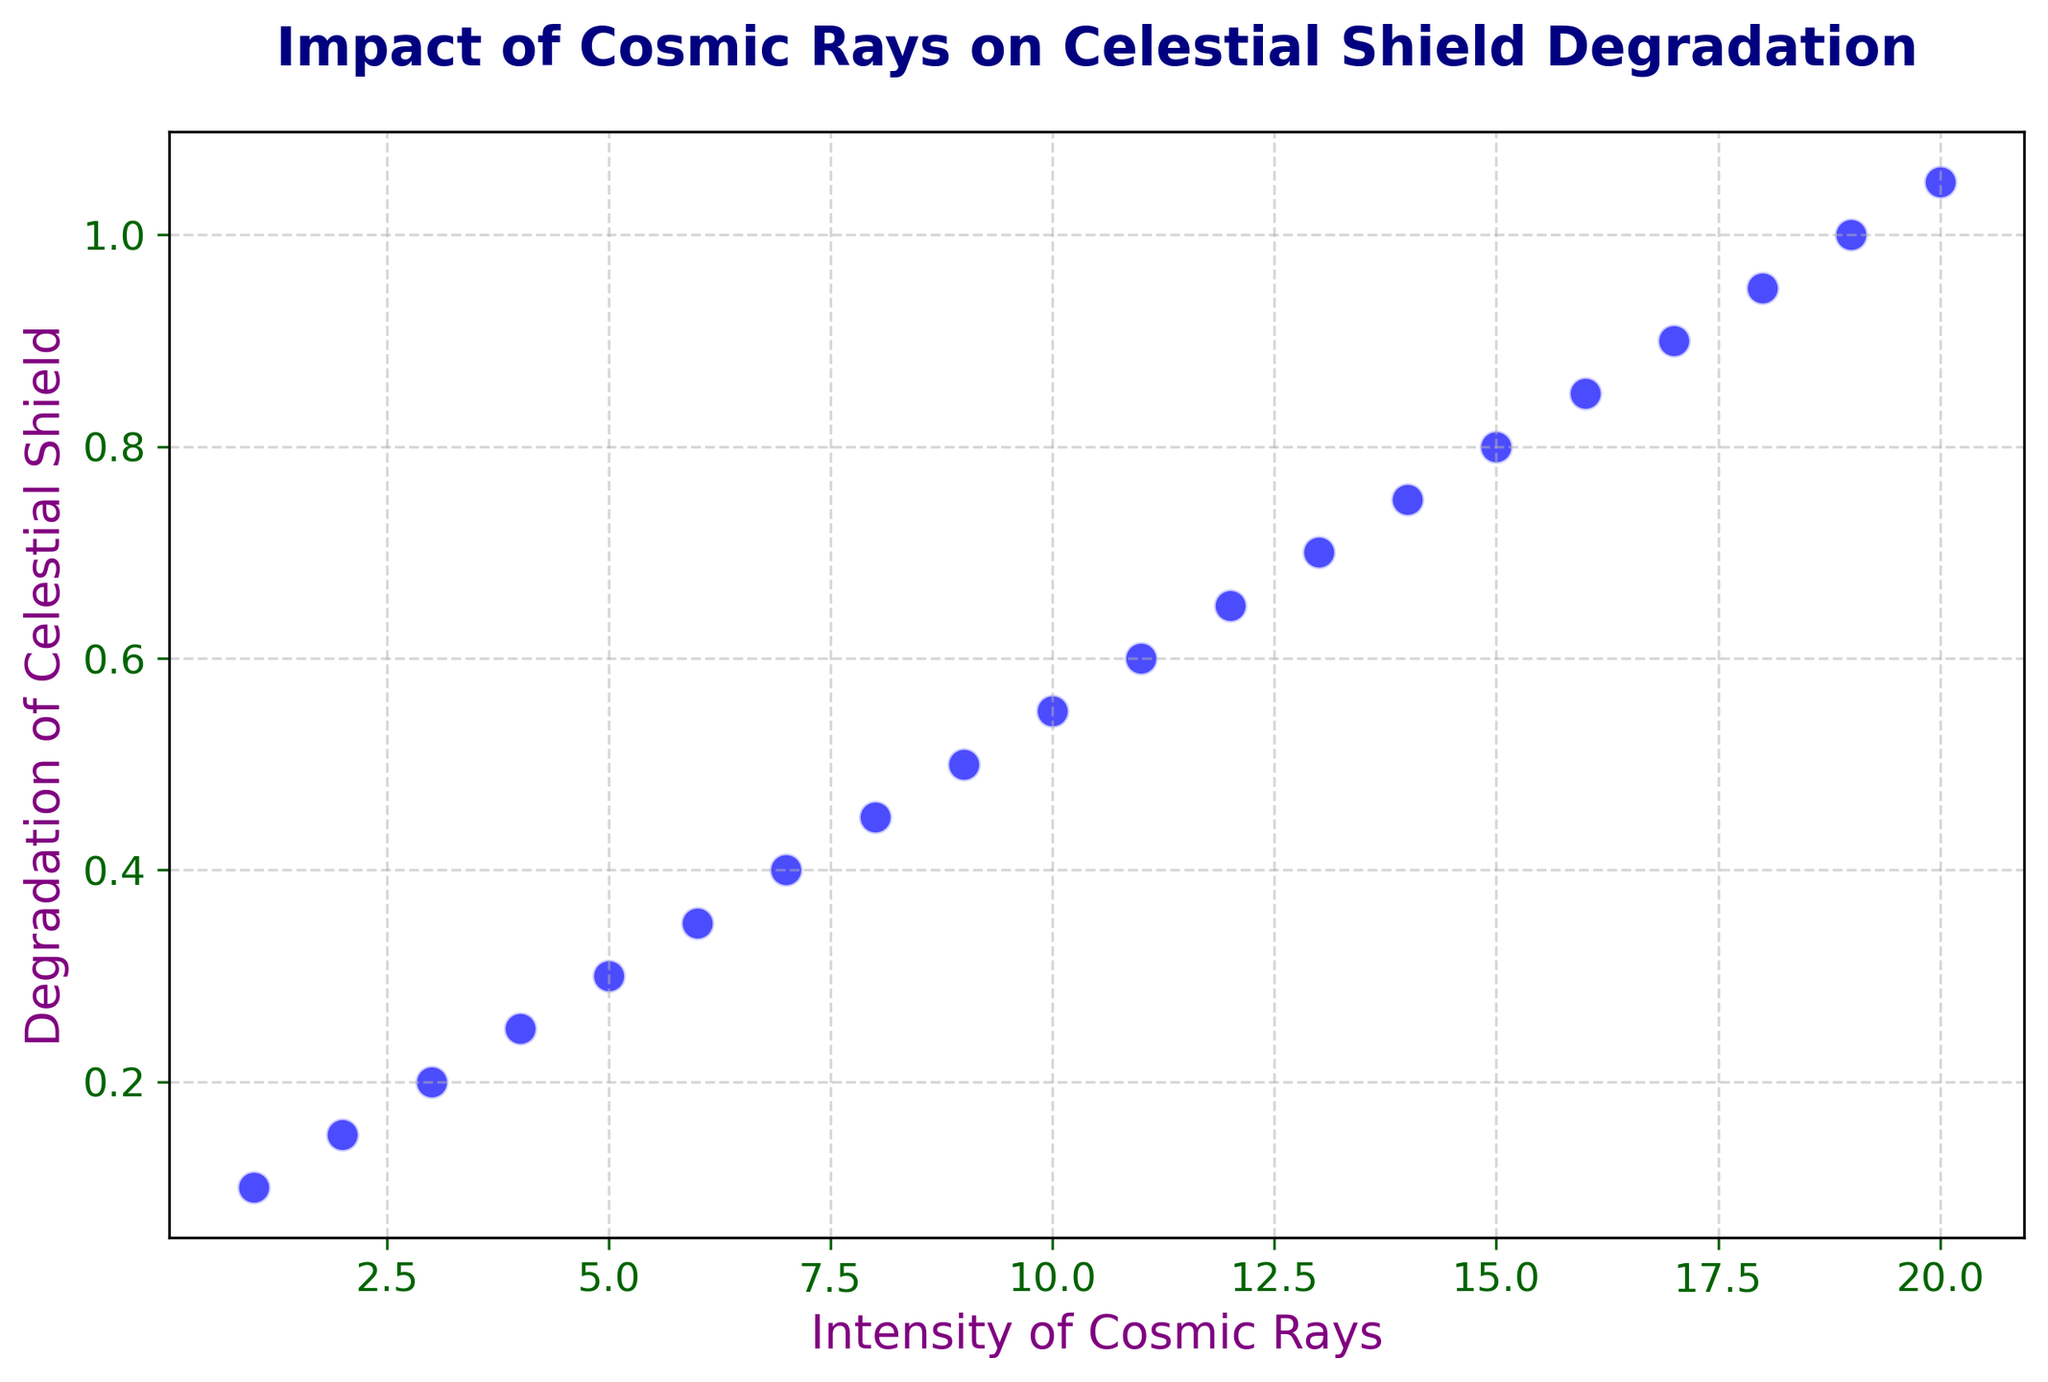What can be observed about the relationship between the intensity of cosmic rays and the degradation of the celestial shield? The scatter plot illustrates a clear and direct linear relationship, showing that as the intensity of cosmic rays increases, the degradation of the celestial shield also increases consistently. Both axes are proportionally scaled and thus any increase in x (cosmic ray intensity) leads predictably to an increase in y (shield degradation).
Answer: The degradation increases linearly with an increase in cosmic ray intensity What is the degradation of the celestial shield when the intensity of cosmic rays is 10? By locating the point corresponding to an x-value of 10 on the scatter plot, we can see that the degradation value (y-axis) at this point is 0.55.
Answer: 0.55 Compare the degradation of the celestial shield at intensity levels 5 and 15. Which one has a higher degradation and by how much? At intensity level 5, the degradation is 0.30. At intensity level 15, the degradation is 0.80. Comparing these, the degradation at intensity level 15 is higher by 0.80 - 0.30 = 0.50.
Answer: 15 has a higher degradation by 0.50 What is the average degradation of the celestial shield for intensities ranging from 1 to 5? The degradation values for intensities 1 to 5 are 0.1, 0.15, 0.2, 0.25, and 0.3. Summing these values gives 0.1 + 0.15 + 0.2 + 0.25 + 0.3 = 1.0. The average is thus 1.0 / 5 = 0.2.
Answer: 0.2 If the degradation reaches 0.9, what intensity of cosmic rays corresponds to this degraded level? On the scatter plot, tracing the degradation level of 0.9 on the y-axis leads us to the corresponding point on the x-axis which shows an intensity level of 17.
Answer: 17 Between intensity levels 8 and 12, how much does the degradation of the celestial shield increase? The degradation values at intensity levels 8 and 12 are 0.45 and 0.65, respectively. The increase in degradation can be calculated as 0.65 - 0.45 = 0.2.
Answer: 0.2 At what intensity of cosmic rays does the degradation of the celestial shield reach 1.0? By examining the scatter plot, the point at which the degradation reaches 1.0 on the y-axis is at an intensity level of 19 on the x-axis.
Answer: 19 Which intensity level has a degradation just above 0.5? Observing the scatter plot, an intensity level of 11 shows a degradation of 0.6, which is the immediate value above 0.5.
Answer: 11 Is there any outlier or point that deviates significantly from the linear relationship observed in the plot? Upon visual inspection of the scatter plot, no data point appears to deviate significantly from the linear trendline. All points adhere closely to the observed linear relationship.
Answer: No What intensity level corresponds to a degradation higher than 0.75 but lower than 0.85? The scatter plot shows that the degradation values between 0.75 and 0.85 correspond to the intensity levels of 15 and 16, respectively.
Answer: 15 and 16 